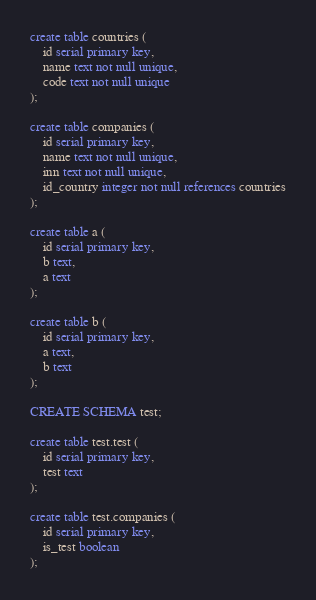Convert code to text. <code><loc_0><loc_0><loc_500><loc_500><_SQL_>create table countries (
    id serial primary key,
    name text not null unique,
    code text not null unique
);

create table companies (
    id serial primary key,
    name text not null unique,
    inn text not null unique,
    id_country integer not null references countries
);

create table a (
    id serial primary key,
    b text,
    a text
);

create table b (
    id serial primary key,
    a text,
    b text
);

CREATE SCHEMA test;

create table test.test (
    id serial primary key,
    test text
);

create table test.companies (
    id serial primary key,
    is_test boolean
);</code> 